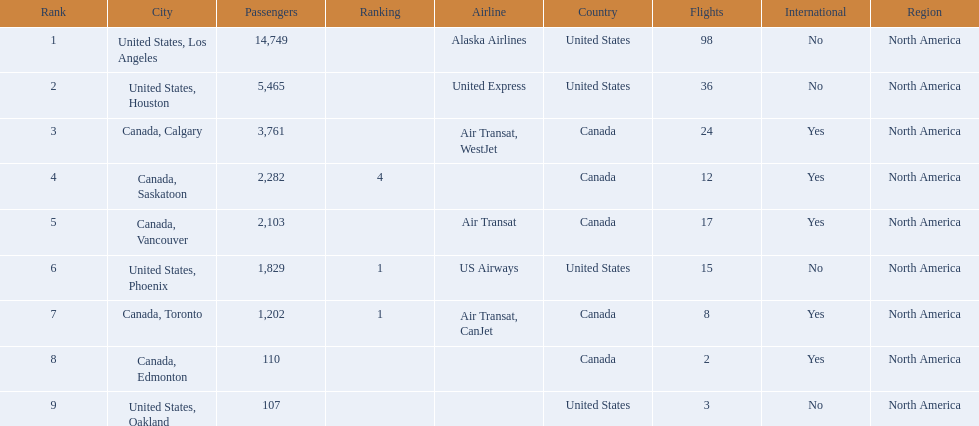What cities do the planes fly to? United States, Los Angeles, United States, Houston, Canada, Calgary, Canada, Saskatoon, Canada, Vancouver, United States, Phoenix, Canada, Toronto, Canada, Edmonton, United States, Oakland. How many people are flying to phoenix, arizona? 1,829. 